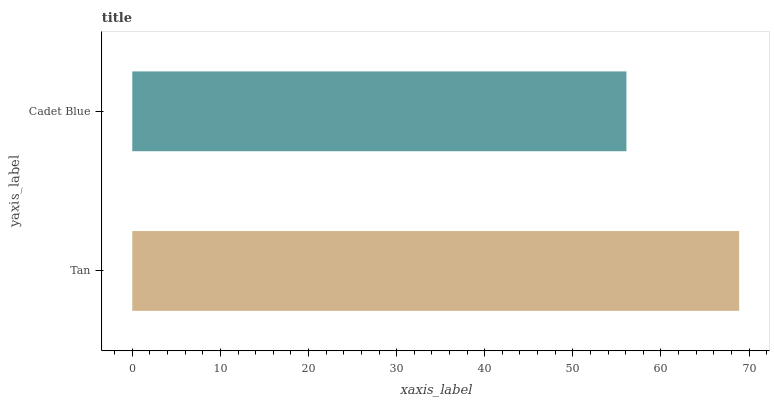Is Cadet Blue the minimum?
Answer yes or no. Yes. Is Tan the maximum?
Answer yes or no. Yes. Is Cadet Blue the maximum?
Answer yes or no. No. Is Tan greater than Cadet Blue?
Answer yes or no. Yes. Is Cadet Blue less than Tan?
Answer yes or no. Yes. Is Cadet Blue greater than Tan?
Answer yes or no. No. Is Tan less than Cadet Blue?
Answer yes or no. No. Is Tan the high median?
Answer yes or no. Yes. Is Cadet Blue the low median?
Answer yes or no. Yes. Is Cadet Blue the high median?
Answer yes or no. No. Is Tan the low median?
Answer yes or no. No. 